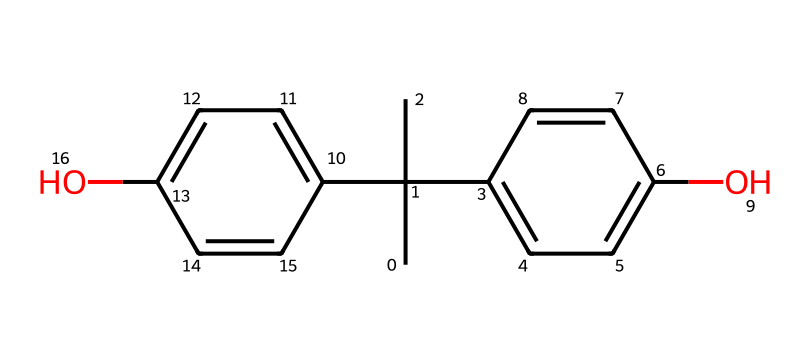What is the name of this chemical? The SMILES representation corresponds to bisphenol A, a common chemical used in the production of plastics and resins.
Answer: bisphenol A How many carbon atoms are present in this structure? By analyzing the SMILES notation, you can count the distinct carbon atoms represented. There are 15 carbon atoms indicated in the structure.
Answer: 15 What type of functional groups are found in this molecule? The SMILES representation indicates the presence of hydroxyl (-OH) groups, which are characteristic of phenolic compounds. Two such hydroxyl groups are present in this structure.
Answer: hydroxyl groups Does this chemical have any aromatic rings? The presence of cyclic structures with alternating double bonds in the SMILES indicates that there are aromatic rings. In this case, two aromatic ring structures are included.
Answer: yes What is the total number of hydroxyl groups in the molecule? The depiction of the molecule in the SMILES shows two -OH groups, which makes it easy to identify how many hydroxyl functional groups are contained within the structure.
Answer: 2 Is bisphenol A considered a hazardous chemical? Yes, bisphenol A is recognized for its potential endocrine-disrupting effects and is classified as a hazardous chemical due to its toxicological properties.
Answer: yes 